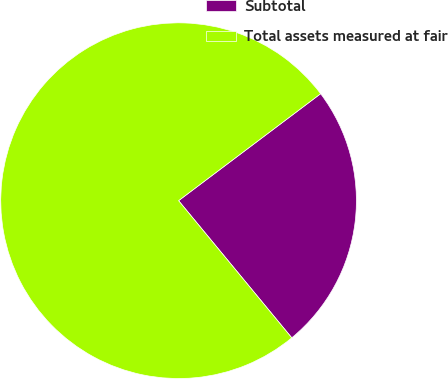Convert chart. <chart><loc_0><loc_0><loc_500><loc_500><pie_chart><fcel>Subtotal<fcel>Total assets measured at fair<nl><fcel>24.29%<fcel>75.71%<nl></chart> 